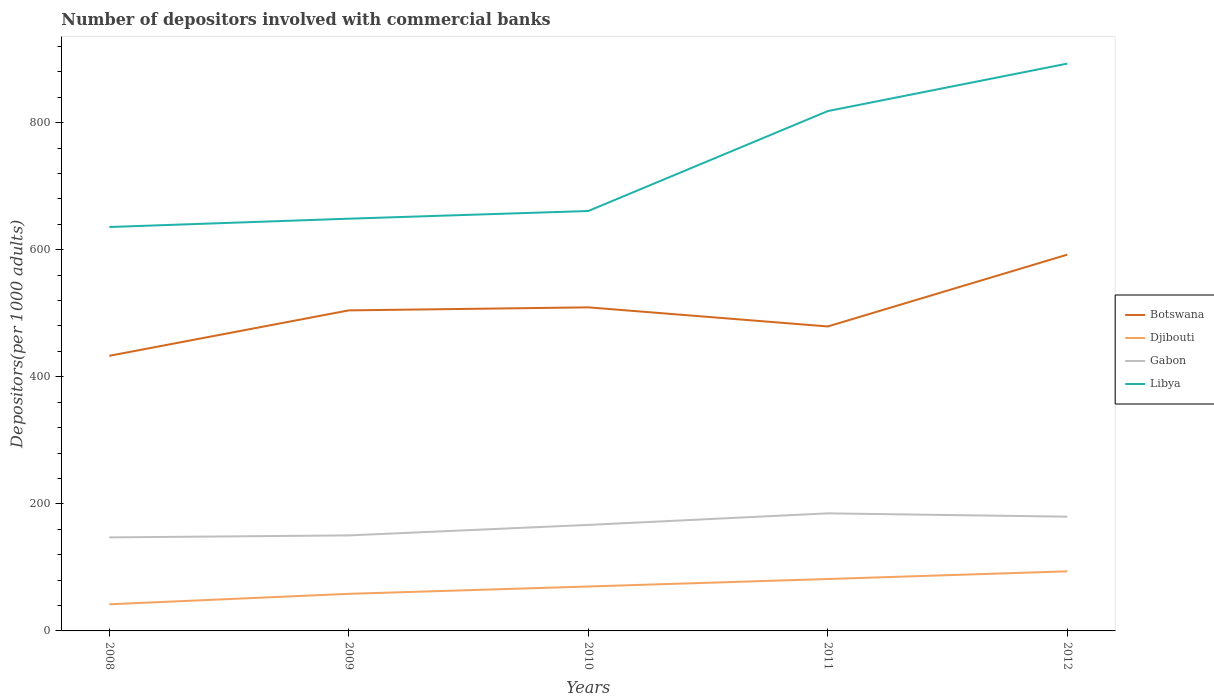How many different coloured lines are there?
Your answer should be compact. 4. Does the line corresponding to Botswana intersect with the line corresponding to Libya?
Provide a short and direct response. No. Across all years, what is the maximum number of depositors involved with commercial banks in Botswana?
Ensure brevity in your answer.  433.02. What is the total number of depositors involved with commercial banks in Libya in the graph?
Provide a succinct answer. -169.37. What is the difference between the highest and the second highest number of depositors involved with commercial banks in Libya?
Offer a terse response. 257.2. Is the number of depositors involved with commercial banks in Gabon strictly greater than the number of depositors involved with commercial banks in Libya over the years?
Give a very brief answer. Yes. Does the graph contain grids?
Make the answer very short. No. How are the legend labels stacked?
Your answer should be very brief. Vertical. What is the title of the graph?
Offer a very short reply. Number of depositors involved with commercial banks. What is the label or title of the X-axis?
Your answer should be compact. Years. What is the label or title of the Y-axis?
Provide a succinct answer. Depositors(per 1000 adults). What is the Depositors(per 1000 adults) in Botswana in 2008?
Your answer should be very brief. 433.02. What is the Depositors(per 1000 adults) in Djibouti in 2008?
Your answer should be compact. 41.94. What is the Depositors(per 1000 adults) of Gabon in 2008?
Your answer should be very brief. 147.22. What is the Depositors(per 1000 adults) in Libya in 2008?
Your response must be concise. 635.76. What is the Depositors(per 1000 adults) in Botswana in 2009?
Your answer should be very brief. 504.55. What is the Depositors(per 1000 adults) of Djibouti in 2009?
Your response must be concise. 58.37. What is the Depositors(per 1000 adults) of Gabon in 2009?
Ensure brevity in your answer.  150.34. What is the Depositors(per 1000 adults) of Libya in 2009?
Your response must be concise. 648.86. What is the Depositors(per 1000 adults) in Botswana in 2010?
Your answer should be very brief. 509.3. What is the Depositors(per 1000 adults) in Djibouti in 2010?
Make the answer very short. 69.91. What is the Depositors(per 1000 adults) of Gabon in 2010?
Your answer should be very brief. 166.87. What is the Depositors(per 1000 adults) of Libya in 2010?
Offer a terse response. 660.95. What is the Depositors(per 1000 adults) in Botswana in 2011?
Provide a succinct answer. 479.22. What is the Depositors(per 1000 adults) in Djibouti in 2011?
Your response must be concise. 81.7. What is the Depositors(per 1000 adults) of Gabon in 2011?
Provide a short and direct response. 185.06. What is the Depositors(per 1000 adults) in Libya in 2011?
Offer a terse response. 818.23. What is the Depositors(per 1000 adults) in Botswana in 2012?
Offer a very short reply. 592.26. What is the Depositors(per 1000 adults) in Djibouti in 2012?
Your response must be concise. 93.79. What is the Depositors(per 1000 adults) in Gabon in 2012?
Your answer should be very brief. 179.84. What is the Depositors(per 1000 adults) in Libya in 2012?
Your answer should be compact. 892.96. Across all years, what is the maximum Depositors(per 1000 adults) in Botswana?
Make the answer very short. 592.26. Across all years, what is the maximum Depositors(per 1000 adults) in Djibouti?
Offer a terse response. 93.79. Across all years, what is the maximum Depositors(per 1000 adults) of Gabon?
Provide a succinct answer. 185.06. Across all years, what is the maximum Depositors(per 1000 adults) in Libya?
Give a very brief answer. 892.96. Across all years, what is the minimum Depositors(per 1000 adults) in Botswana?
Make the answer very short. 433.02. Across all years, what is the minimum Depositors(per 1000 adults) in Djibouti?
Your response must be concise. 41.94. Across all years, what is the minimum Depositors(per 1000 adults) in Gabon?
Keep it short and to the point. 147.22. Across all years, what is the minimum Depositors(per 1000 adults) in Libya?
Make the answer very short. 635.76. What is the total Depositors(per 1000 adults) of Botswana in the graph?
Keep it short and to the point. 2518.35. What is the total Depositors(per 1000 adults) of Djibouti in the graph?
Your answer should be compact. 345.72. What is the total Depositors(per 1000 adults) in Gabon in the graph?
Your response must be concise. 829.33. What is the total Depositors(per 1000 adults) of Libya in the graph?
Provide a short and direct response. 3656.76. What is the difference between the Depositors(per 1000 adults) of Botswana in 2008 and that in 2009?
Give a very brief answer. -71.53. What is the difference between the Depositors(per 1000 adults) of Djibouti in 2008 and that in 2009?
Your response must be concise. -16.44. What is the difference between the Depositors(per 1000 adults) of Gabon in 2008 and that in 2009?
Provide a short and direct response. -3.11. What is the difference between the Depositors(per 1000 adults) in Libya in 2008 and that in 2009?
Make the answer very short. -13.1. What is the difference between the Depositors(per 1000 adults) of Botswana in 2008 and that in 2010?
Keep it short and to the point. -76.28. What is the difference between the Depositors(per 1000 adults) of Djibouti in 2008 and that in 2010?
Ensure brevity in your answer.  -27.97. What is the difference between the Depositors(per 1000 adults) of Gabon in 2008 and that in 2010?
Offer a terse response. -19.65. What is the difference between the Depositors(per 1000 adults) of Libya in 2008 and that in 2010?
Your answer should be compact. -25.19. What is the difference between the Depositors(per 1000 adults) of Botswana in 2008 and that in 2011?
Make the answer very short. -46.21. What is the difference between the Depositors(per 1000 adults) of Djibouti in 2008 and that in 2011?
Keep it short and to the point. -39.77. What is the difference between the Depositors(per 1000 adults) in Gabon in 2008 and that in 2011?
Ensure brevity in your answer.  -37.83. What is the difference between the Depositors(per 1000 adults) in Libya in 2008 and that in 2011?
Your response must be concise. -182.47. What is the difference between the Depositors(per 1000 adults) of Botswana in 2008 and that in 2012?
Your response must be concise. -159.25. What is the difference between the Depositors(per 1000 adults) of Djibouti in 2008 and that in 2012?
Give a very brief answer. -51.86. What is the difference between the Depositors(per 1000 adults) in Gabon in 2008 and that in 2012?
Give a very brief answer. -32.62. What is the difference between the Depositors(per 1000 adults) of Libya in 2008 and that in 2012?
Provide a succinct answer. -257.2. What is the difference between the Depositors(per 1000 adults) of Botswana in 2009 and that in 2010?
Provide a short and direct response. -4.75. What is the difference between the Depositors(per 1000 adults) of Djibouti in 2009 and that in 2010?
Give a very brief answer. -11.54. What is the difference between the Depositors(per 1000 adults) of Gabon in 2009 and that in 2010?
Keep it short and to the point. -16.54. What is the difference between the Depositors(per 1000 adults) in Libya in 2009 and that in 2010?
Your answer should be very brief. -12.09. What is the difference between the Depositors(per 1000 adults) of Botswana in 2009 and that in 2011?
Make the answer very short. 25.33. What is the difference between the Depositors(per 1000 adults) in Djibouti in 2009 and that in 2011?
Provide a short and direct response. -23.33. What is the difference between the Depositors(per 1000 adults) in Gabon in 2009 and that in 2011?
Your answer should be compact. -34.72. What is the difference between the Depositors(per 1000 adults) in Libya in 2009 and that in 2011?
Provide a succinct answer. -169.37. What is the difference between the Depositors(per 1000 adults) in Botswana in 2009 and that in 2012?
Your answer should be compact. -87.71. What is the difference between the Depositors(per 1000 adults) in Djibouti in 2009 and that in 2012?
Give a very brief answer. -35.42. What is the difference between the Depositors(per 1000 adults) in Gabon in 2009 and that in 2012?
Give a very brief answer. -29.5. What is the difference between the Depositors(per 1000 adults) of Libya in 2009 and that in 2012?
Your answer should be compact. -244.1. What is the difference between the Depositors(per 1000 adults) of Botswana in 2010 and that in 2011?
Your response must be concise. 30.08. What is the difference between the Depositors(per 1000 adults) of Djibouti in 2010 and that in 2011?
Ensure brevity in your answer.  -11.79. What is the difference between the Depositors(per 1000 adults) in Gabon in 2010 and that in 2011?
Provide a short and direct response. -18.18. What is the difference between the Depositors(per 1000 adults) of Libya in 2010 and that in 2011?
Give a very brief answer. -157.27. What is the difference between the Depositors(per 1000 adults) in Botswana in 2010 and that in 2012?
Give a very brief answer. -82.96. What is the difference between the Depositors(per 1000 adults) in Djibouti in 2010 and that in 2012?
Keep it short and to the point. -23.88. What is the difference between the Depositors(per 1000 adults) in Gabon in 2010 and that in 2012?
Your answer should be very brief. -12.97. What is the difference between the Depositors(per 1000 adults) of Libya in 2010 and that in 2012?
Ensure brevity in your answer.  -232. What is the difference between the Depositors(per 1000 adults) of Botswana in 2011 and that in 2012?
Offer a very short reply. -113.04. What is the difference between the Depositors(per 1000 adults) of Djibouti in 2011 and that in 2012?
Your response must be concise. -12.09. What is the difference between the Depositors(per 1000 adults) of Gabon in 2011 and that in 2012?
Offer a very short reply. 5.22. What is the difference between the Depositors(per 1000 adults) of Libya in 2011 and that in 2012?
Your response must be concise. -74.73. What is the difference between the Depositors(per 1000 adults) in Botswana in 2008 and the Depositors(per 1000 adults) in Djibouti in 2009?
Your answer should be compact. 374.64. What is the difference between the Depositors(per 1000 adults) of Botswana in 2008 and the Depositors(per 1000 adults) of Gabon in 2009?
Make the answer very short. 282.68. What is the difference between the Depositors(per 1000 adults) in Botswana in 2008 and the Depositors(per 1000 adults) in Libya in 2009?
Your answer should be very brief. -215.84. What is the difference between the Depositors(per 1000 adults) of Djibouti in 2008 and the Depositors(per 1000 adults) of Gabon in 2009?
Provide a succinct answer. -108.4. What is the difference between the Depositors(per 1000 adults) in Djibouti in 2008 and the Depositors(per 1000 adults) in Libya in 2009?
Your answer should be very brief. -606.93. What is the difference between the Depositors(per 1000 adults) in Gabon in 2008 and the Depositors(per 1000 adults) in Libya in 2009?
Offer a terse response. -501.64. What is the difference between the Depositors(per 1000 adults) in Botswana in 2008 and the Depositors(per 1000 adults) in Djibouti in 2010?
Give a very brief answer. 363.11. What is the difference between the Depositors(per 1000 adults) of Botswana in 2008 and the Depositors(per 1000 adults) of Gabon in 2010?
Your answer should be very brief. 266.14. What is the difference between the Depositors(per 1000 adults) of Botswana in 2008 and the Depositors(per 1000 adults) of Libya in 2010?
Offer a terse response. -227.94. What is the difference between the Depositors(per 1000 adults) in Djibouti in 2008 and the Depositors(per 1000 adults) in Gabon in 2010?
Keep it short and to the point. -124.94. What is the difference between the Depositors(per 1000 adults) of Djibouti in 2008 and the Depositors(per 1000 adults) of Libya in 2010?
Provide a short and direct response. -619.02. What is the difference between the Depositors(per 1000 adults) of Gabon in 2008 and the Depositors(per 1000 adults) of Libya in 2010?
Offer a terse response. -513.73. What is the difference between the Depositors(per 1000 adults) in Botswana in 2008 and the Depositors(per 1000 adults) in Djibouti in 2011?
Provide a short and direct response. 351.32. What is the difference between the Depositors(per 1000 adults) of Botswana in 2008 and the Depositors(per 1000 adults) of Gabon in 2011?
Your answer should be compact. 247.96. What is the difference between the Depositors(per 1000 adults) in Botswana in 2008 and the Depositors(per 1000 adults) in Libya in 2011?
Your response must be concise. -385.21. What is the difference between the Depositors(per 1000 adults) of Djibouti in 2008 and the Depositors(per 1000 adults) of Gabon in 2011?
Give a very brief answer. -143.12. What is the difference between the Depositors(per 1000 adults) in Djibouti in 2008 and the Depositors(per 1000 adults) in Libya in 2011?
Provide a succinct answer. -776.29. What is the difference between the Depositors(per 1000 adults) in Gabon in 2008 and the Depositors(per 1000 adults) in Libya in 2011?
Your response must be concise. -671.01. What is the difference between the Depositors(per 1000 adults) in Botswana in 2008 and the Depositors(per 1000 adults) in Djibouti in 2012?
Keep it short and to the point. 339.22. What is the difference between the Depositors(per 1000 adults) in Botswana in 2008 and the Depositors(per 1000 adults) in Gabon in 2012?
Your answer should be compact. 253.18. What is the difference between the Depositors(per 1000 adults) in Botswana in 2008 and the Depositors(per 1000 adults) in Libya in 2012?
Your response must be concise. -459.94. What is the difference between the Depositors(per 1000 adults) of Djibouti in 2008 and the Depositors(per 1000 adults) of Gabon in 2012?
Your answer should be compact. -137.91. What is the difference between the Depositors(per 1000 adults) in Djibouti in 2008 and the Depositors(per 1000 adults) in Libya in 2012?
Your answer should be compact. -851.02. What is the difference between the Depositors(per 1000 adults) of Gabon in 2008 and the Depositors(per 1000 adults) of Libya in 2012?
Keep it short and to the point. -745.73. What is the difference between the Depositors(per 1000 adults) in Botswana in 2009 and the Depositors(per 1000 adults) in Djibouti in 2010?
Keep it short and to the point. 434.64. What is the difference between the Depositors(per 1000 adults) in Botswana in 2009 and the Depositors(per 1000 adults) in Gabon in 2010?
Provide a succinct answer. 337.68. What is the difference between the Depositors(per 1000 adults) of Botswana in 2009 and the Depositors(per 1000 adults) of Libya in 2010?
Ensure brevity in your answer.  -156.41. What is the difference between the Depositors(per 1000 adults) of Djibouti in 2009 and the Depositors(per 1000 adults) of Gabon in 2010?
Ensure brevity in your answer.  -108.5. What is the difference between the Depositors(per 1000 adults) of Djibouti in 2009 and the Depositors(per 1000 adults) of Libya in 2010?
Ensure brevity in your answer.  -602.58. What is the difference between the Depositors(per 1000 adults) of Gabon in 2009 and the Depositors(per 1000 adults) of Libya in 2010?
Keep it short and to the point. -510.62. What is the difference between the Depositors(per 1000 adults) in Botswana in 2009 and the Depositors(per 1000 adults) in Djibouti in 2011?
Offer a very short reply. 422.85. What is the difference between the Depositors(per 1000 adults) in Botswana in 2009 and the Depositors(per 1000 adults) in Gabon in 2011?
Give a very brief answer. 319.49. What is the difference between the Depositors(per 1000 adults) in Botswana in 2009 and the Depositors(per 1000 adults) in Libya in 2011?
Offer a terse response. -313.68. What is the difference between the Depositors(per 1000 adults) of Djibouti in 2009 and the Depositors(per 1000 adults) of Gabon in 2011?
Make the answer very short. -126.68. What is the difference between the Depositors(per 1000 adults) of Djibouti in 2009 and the Depositors(per 1000 adults) of Libya in 2011?
Offer a very short reply. -759.85. What is the difference between the Depositors(per 1000 adults) in Gabon in 2009 and the Depositors(per 1000 adults) in Libya in 2011?
Your answer should be very brief. -667.89. What is the difference between the Depositors(per 1000 adults) of Botswana in 2009 and the Depositors(per 1000 adults) of Djibouti in 2012?
Offer a terse response. 410.75. What is the difference between the Depositors(per 1000 adults) in Botswana in 2009 and the Depositors(per 1000 adults) in Gabon in 2012?
Offer a very short reply. 324.71. What is the difference between the Depositors(per 1000 adults) of Botswana in 2009 and the Depositors(per 1000 adults) of Libya in 2012?
Offer a terse response. -388.41. What is the difference between the Depositors(per 1000 adults) in Djibouti in 2009 and the Depositors(per 1000 adults) in Gabon in 2012?
Provide a succinct answer. -121.47. What is the difference between the Depositors(per 1000 adults) of Djibouti in 2009 and the Depositors(per 1000 adults) of Libya in 2012?
Your response must be concise. -834.58. What is the difference between the Depositors(per 1000 adults) of Gabon in 2009 and the Depositors(per 1000 adults) of Libya in 2012?
Your answer should be compact. -742.62. What is the difference between the Depositors(per 1000 adults) in Botswana in 2010 and the Depositors(per 1000 adults) in Djibouti in 2011?
Your answer should be compact. 427.6. What is the difference between the Depositors(per 1000 adults) of Botswana in 2010 and the Depositors(per 1000 adults) of Gabon in 2011?
Make the answer very short. 324.24. What is the difference between the Depositors(per 1000 adults) of Botswana in 2010 and the Depositors(per 1000 adults) of Libya in 2011?
Your response must be concise. -308.93. What is the difference between the Depositors(per 1000 adults) in Djibouti in 2010 and the Depositors(per 1000 adults) in Gabon in 2011?
Your response must be concise. -115.15. What is the difference between the Depositors(per 1000 adults) in Djibouti in 2010 and the Depositors(per 1000 adults) in Libya in 2011?
Your response must be concise. -748.32. What is the difference between the Depositors(per 1000 adults) of Gabon in 2010 and the Depositors(per 1000 adults) of Libya in 2011?
Your response must be concise. -651.36. What is the difference between the Depositors(per 1000 adults) of Botswana in 2010 and the Depositors(per 1000 adults) of Djibouti in 2012?
Give a very brief answer. 415.51. What is the difference between the Depositors(per 1000 adults) of Botswana in 2010 and the Depositors(per 1000 adults) of Gabon in 2012?
Provide a short and direct response. 329.46. What is the difference between the Depositors(per 1000 adults) of Botswana in 2010 and the Depositors(per 1000 adults) of Libya in 2012?
Your response must be concise. -383.66. What is the difference between the Depositors(per 1000 adults) in Djibouti in 2010 and the Depositors(per 1000 adults) in Gabon in 2012?
Give a very brief answer. -109.93. What is the difference between the Depositors(per 1000 adults) of Djibouti in 2010 and the Depositors(per 1000 adults) of Libya in 2012?
Your answer should be very brief. -823.05. What is the difference between the Depositors(per 1000 adults) in Gabon in 2010 and the Depositors(per 1000 adults) in Libya in 2012?
Make the answer very short. -726.08. What is the difference between the Depositors(per 1000 adults) in Botswana in 2011 and the Depositors(per 1000 adults) in Djibouti in 2012?
Provide a succinct answer. 385.43. What is the difference between the Depositors(per 1000 adults) in Botswana in 2011 and the Depositors(per 1000 adults) in Gabon in 2012?
Provide a succinct answer. 299.38. What is the difference between the Depositors(per 1000 adults) of Botswana in 2011 and the Depositors(per 1000 adults) of Libya in 2012?
Provide a short and direct response. -413.73. What is the difference between the Depositors(per 1000 adults) of Djibouti in 2011 and the Depositors(per 1000 adults) of Gabon in 2012?
Your response must be concise. -98.14. What is the difference between the Depositors(per 1000 adults) of Djibouti in 2011 and the Depositors(per 1000 adults) of Libya in 2012?
Your response must be concise. -811.25. What is the difference between the Depositors(per 1000 adults) in Gabon in 2011 and the Depositors(per 1000 adults) in Libya in 2012?
Make the answer very short. -707.9. What is the average Depositors(per 1000 adults) of Botswana per year?
Give a very brief answer. 503.67. What is the average Depositors(per 1000 adults) in Djibouti per year?
Provide a succinct answer. 69.14. What is the average Depositors(per 1000 adults) of Gabon per year?
Ensure brevity in your answer.  165.87. What is the average Depositors(per 1000 adults) in Libya per year?
Your response must be concise. 731.35. In the year 2008, what is the difference between the Depositors(per 1000 adults) in Botswana and Depositors(per 1000 adults) in Djibouti?
Keep it short and to the point. 391.08. In the year 2008, what is the difference between the Depositors(per 1000 adults) of Botswana and Depositors(per 1000 adults) of Gabon?
Keep it short and to the point. 285.79. In the year 2008, what is the difference between the Depositors(per 1000 adults) in Botswana and Depositors(per 1000 adults) in Libya?
Keep it short and to the point. -202.74. In the year 2008, what is the difference between the Depositors(per 1000 adults) in Djibouti and Depositors(per 1000 adults) in Gabon?
Offer a very short reply. -105.29. In the year 2008, what is the difference between the Depositors(per 1000 adults) in Djibouti and Depositors(per 1000 adults) in Libya?
Provide a succinct answer. -593.83. In the year 2008, what is the difference between the Depositors(per 1000 adults) in Gabon and Depositors(per 1000 adults) in Libya?
Offer a very short reply. -488.54. In the year 2009, what is the difference between the Depositors(per 1000 adults) in Botswana and Depositors(per 1000 adults) in Djibouti?
Offer a very short reply. 446.17. In the year 2009, what is the difference between the Depositors(per 1000 adults) of Botswana and Depositors(per 1000 adults) of Gabon?
Your response must be concise. 354.21. In the year 2009, what is the difference between the Depositors(per 1000 adults) of Botswana and Depositors(per 1000 adults) of Libya?
Give a very brief answer. -144.31. In the year 2009, what is the difference between the Depositors(per 1000 adults) of Djibouti and Depositors(per 1000 adults) of Gabon?
Ensure brevity in your answer.  -91.96. In the year 2009, what is the difference between the Depositors(per 1000 adults) in Djibouti and Depositors(per 1000 adults) in Libya?
Offer a terse response. -590.49. In the year 2009, what is the difference between the Depositors(per 1000 adults) of Gabon and Depositors(per 1000 adults) of Libya?
Your response must be concise. -498.52. In the year 2010, what is the difference between the Depositors(per 1000 adults) in Botswana and Depositors(per 1000 adults) in Djibouti?
Offer a terse response. 439.39. In the year 2010, what is the difference between the Depositors(per 1000 adults) of Botswana and Depositors(per 1000 adults) of Gabon?
Ensure brevity in your answer.  342.43. In the year 2010, what is the difference between the Depositors(per 1000 adults) of Botswana and Depositors(per 1000 adults) of Libya?
Keep it short and to the point. -151.65. In the year 2010, what is the difference between the Depositors(per 1000 adults) in Djibouti and Depositors(per 1000 adults) in Gabon?
Your response must be concise. -96.96. In the year 2010, what is the difference between the Depositors(per 1000 adults) in Djibouti and Depositors(per 1000 adults) in Libya?
Provide a succinct answer. -591.04. In the year 2010, what is the difference between the Depositors(per 1000 adults) in Gabon and Depositors(per 1000 adults) in Libya?
Ensure brevity in your answer.  -494.08. In the year 2011, what is the difference between the Depositors(per 1000 adults) of Botswana and Depositors(per 1000 adults) of Djibouti?
Ensure brevity in your answer.  397.52. In the year 2011, what is the difference between the Depositors(per 1000 adults) in Botswana and Depositors(per 1000 adults) in Gabon?
Provide a succinct answer. 294.17. In the year 2011, what is the difference between the Depositors(per 1000 adults) of Botswana and Depositors(per 1000 adults) of Libya?
Your answer should be very brief. -339.01. In the year 2011, what is the difference between the Depositors(per 1000 adults) in Djibouti and Depositors(per 1000 adults) in Gabon?
Your answer should be compact. -103.36. In the year 2011, what is the difference between the Depositors(per 1000 adults) in Djibouti and Depositors(per 1000 adults) in Libya?
Your answer should be very brief. -736.53. In the year 2011, what is the difference between the Depositors(per 1000 adults) of Gabon and Depositors(per 1000 adults) of Libya?
Provide a succinct answer. -633.17. In the year 2012, what is the difference between the Depositors(per 1000 adults) in Botswana and Depositors(per 1000 adults) in Djibouti?
Offer a very short reply. 498.47. In the year 2012, what is the difference between the Depositors(per 1000 adults) of Botswana and Depositors(per 1000 adults) of Gabon?
Provide a short and direct response. 412.42. In the year 2012, what is the difference between the Depositors(per 1000 adults) in Botswana and Depositors(per 1000 adults) in Libya?
Your answer should be compact. -300.69. In the year 2012, what is the difference between the Depositors(per 1000 adults) of Djibouti and Depositors(per 1000 adults) of Gabon?
Keep it short and to the point. -86.05. In the year 2012, what is the difference between the Depositors(per 1000 adults) in Djibouti and Depositors(per 1000 adults) in Libya?
Your answer should be compact. -799.16. In the year 2012, what is the difference between the Depositors(per 1000 adults) of Gabon and Depositors(per 1000 adults) of Libya?
Make the answer very short. -713.12. What is the ratio of the Depositors(per 1000 adults) of Botswana in 2008 to that in 2009?
Keep it short and to the point. 0.86. What is the ratio of the Depositors(per 1000 adults) of Djibouti in 2008 to that in 2009?
Ensure brevity in your answer.  0.72. What is the ratio of the Depositors(per 1000 adults) in Gabon in 2008 to that in 2009?
Offer a terse response. 0.98. What is the ratio of the Depositors(per 1000 adults) of Libya in 2008 to that in 2009?
Ensure brevity in your answer.  0.98. What is the ratio of the Depositors(per 1000 adults) of Botswana in 2008 to that in 2010?
Make the answer very short. 0.85. What is the ratio of the Depositors(per 1000 adults) in Djibouti in 2008 to that in 2010?
Keep it short and to the point. 0.6. What is the ratio of the Depositors(per 1000 adults) of Gabon in 2008 to that in 2010?
Give a very brief answer. 0.88. What is the ratio of the Depositors(per 1000 adults) in Libya in 2008 to that in 2010?
Make the answer very short. 0.96. What is the ratio of the Depositors(per 1000 adults) in Botswana in 2008 to that in 2011?
Provide a succinct answer. 0.9. What is the ratio of the Depositors(per 1000 adults) in Djibouti in 2008 to that in 2011?
Ensure brevity in your answer.  0.51. What is the ratio of the Depositors(per 1000 adults) in Gabon in 2008 to that in 2011?
Provide a succinct answer. 0.8. What is the ratio of the Depositors(per 1000 adults) of Libya in 2008 to that in 2011?
Offer a terse response. 0.78. What is the ratio of the Depositors(per 1000 adults) of Botswana in 2008 to that in 2012?
Provide a short and direct response. 0.73. What is the ratio of the Depositors(per 1000 adults) in Djibouti in 2008 to that in 2012?
Provide a succinct answer. 0.45. What is the ratio of the Depositors(per 1000 adults) in Gabon in 2008 to that in 2012?
Ensure brevity in your answer.  0.82. What is the ratio of the Depositors(per 1000 adults) in Libya in 2008 to that in 2012?
Keep it short and to the point. 0.71. What is the ratio of the Depositors(per 1000 adults) of Botswana in 2009 to that in 2010?
Ensure brevity in your answer.  0.99. What is the ratio of the Depositors(per 1000 adults) of Djibouti in 2009 to that in 2010?
Give a very brief answer. 0.83. What is the ratio of the Depositors(per 1000 adults) of Gabon in 2009 to that in 2010?
Provide a short and direct response. 0.9. What is the ratio of the Depositors(per 1000 adults) in Libya in 2009 to that in 2010?
Make the answer very short. 0.98. What is the ratio of the Depositors(per 1000 adults) in Botswana in 2009 to that in 2011?
Give a very brief answer. 1.05. What is the ratio of the Depositors(per 1000 adults) in Djibouti in 2009 to that in 2011?
Your answer should be compact. 0.71. What is the ratio of the Depositors(per 1000 adults) in Gabon in 2009 to that in 2011?
Provide a succinct answer. 0.81. What is the ratio of the Depositors(per 1000 adults) of Libya in 2009 to that in 2011?
Offer a terse response. 0.79. What is the ratio of the Depositors(per 1000 adults) of Botswana in 2009 to that in 2012?
Give a very brief answer. 0.85. What is the ratio of the Depositors(per 1000 adults) in Djibouti in 2009 to that in 2012?
Keep it short and to the point. 0.62. What is the ratio of the Depositors(per 1000 adults) of Gabon in 2009 to that in 2012?
Ensure brevity in your answer.  0.84. What is the ratio of the Depositors(per 1000 adults) in Libya in 2009 to that in 2012?
Provide a short and direct response. 0.73. What is the ratio of the Depositors(per 1000 adults) in Botswana in 2010 to that in 2011?
Keep it short and to the point. 1.06. What is the ratio of the Depositors(per 1000 adults) of Djibouti in 2010 to that in 2011?
Your response must be concise. 0.86. What is the ratio of the Depositors(per 1000 adults) in Gabon in 2010 to that in 2011?
Give a very brief answer. 0.9. What is the ratio of the Depositors(per 1000 adults) of Libya in 2010 to that in 2011?
Make the answer very short. 0.81. What is the ratio of the Depositors(per 1000 adults) of Botswana in 2010 to that in 2012?
Your answer should be compact. 0.86. What is the ratio of the Depositors(per 1000 adults) in Djibouti in 2010 to that in 2012?
Offer a very short reply. 0.75. What is the ratio of the Depositors(per 1000 adults) of Gabon in 2010 to that in 2012?
Your answer should be very brief. 0.93. What is the ratio of the Depositors(per 1000 adults) in Libya in 2010 to that in 2012?
Offer a very short reply. 0.74. What is the ratio of the Depositors(per 1000 adults) of Botswana in 2011 to that in 2012?
Make the answer very short. 0.81. What is the ratio of the Depositors(per 1000 adults) of Djibouti in 2011 to that in 2012?
Make the answer very short. 0.87. What is the ratio of the Depositors(per 1000 adults) of Gabon in 2011 to that in 2012?
Offer a terse response. 1.03. What is the ratio of the Depositors(per 1000 adults) of Libya in 2011 to that in 2012?
Your answer should be compact. 0.92. What is the difference between the highest and the second highest Depositors(per 1000 adults) in Botswana?
Make the answer very short. 82.96. What is the difference between the highest and the second highest Depositors(per 1000 adults) in Djibouti?
Provide a succinct answer. 12.09. What is the difference between the highest and the second highest Depositors(per 1000 adults) in Gabon?
Provide a succinct answer. 5.22. What is the difference between the highest and the second highest Depositors(per 1000 adults) of Libya?
Give a very brief answer. 74.73. What is the difference between the highest and the lowest Depositors(per 1000 adults) in Botswana?
Provide a succinct answer. 159.25. What is the difference between the highest and the lowest Depositors(per 1000 adults) of Djibouti?
Keep it short and to the point. 51.86. What is the difference between the highest and the lowest Depositors(per 1000 adults) of Gabon?
Keep it short and to the point. 37.83. What is the difference between the highest and the lowest Depositors(per 1000 adults) of Libya?
Ensure brevity in your answer.  257.2. 